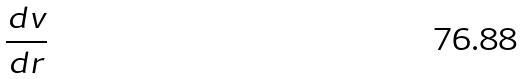<formula> <loc_0><loc_0><loc_500><loc_500>\frac { d v } { d r }</formula> 